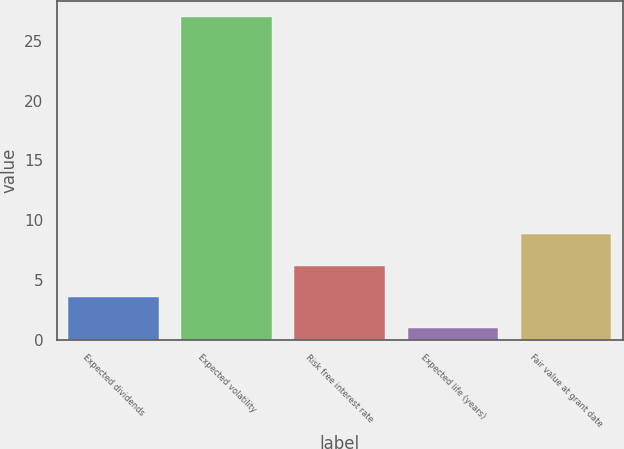Convert chart to OTSL. <chart><loc_0><loc_0><loc_500><loc_500><bar_chart><fcel>Expected dividends<fcel>Expected volatility<fcel>Risk free interest rate<fcel>Expected life (years)<fcel>Fair value at grant date<nl><fcel>3.6<fcel>27<fcel>6.2<fcel>1<fcel>8.8<nl></chart> 